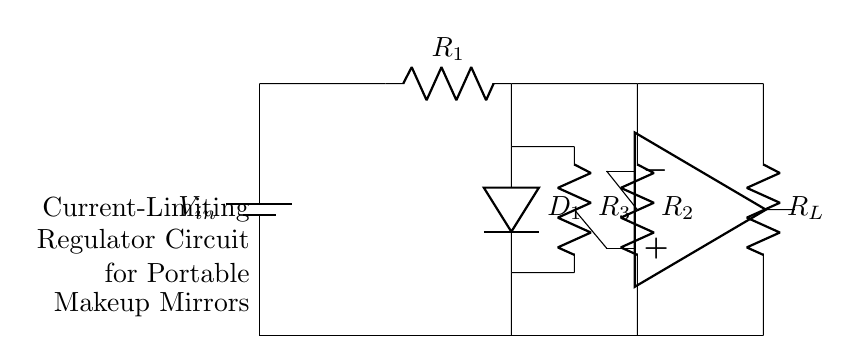What is the input voltage of the circuit? The input voltage is represented as V-in in the circuit diagram, which refers to the source voltage supplied to the regulator.
Answer: V-in What type of components are used in this circuit? The circuit includes resistors, a diode, an operational amplifier, and a battery, which are standard components necessary for a current-limiting regulator.
Answer: Resistors, diode, op-amp, battery How many resistors are present in the circuit? Counting the resistors in the circuit diagram, there are three resistors labeled R1, R2, and R3.
Answer: Three What is the role of the operational amplifier in this circuit? The operational amplifier compares the voltages and helps regulate the current flowing through the load, making it essential for maintaining stable operation in the current-limiting regulator.
Answer: Regulation If R1 is 100 ohms and R2 is 200 ohms, what is the total resistance across the resistors in series? Since R1 and R2 are in series, their resistances add up directly: R1 (100 ohms) + R2 (200 ohms) = 300 ohms.
Answer: 300 ohms What is the purpose of the diode in this circuit? The diode's purpose is to allow current to flow in only one direction, preventing reverse polarity and protecting sensitive components from damage.
Answer: Protection What is the design specific to this regulator circuit for its intended application? The design ensures current limiting to protect sensitive electronic components found in portable makeup mirrors, which are more vulnerable to overcurrent conditions.
Answer: Current limiting for protection 